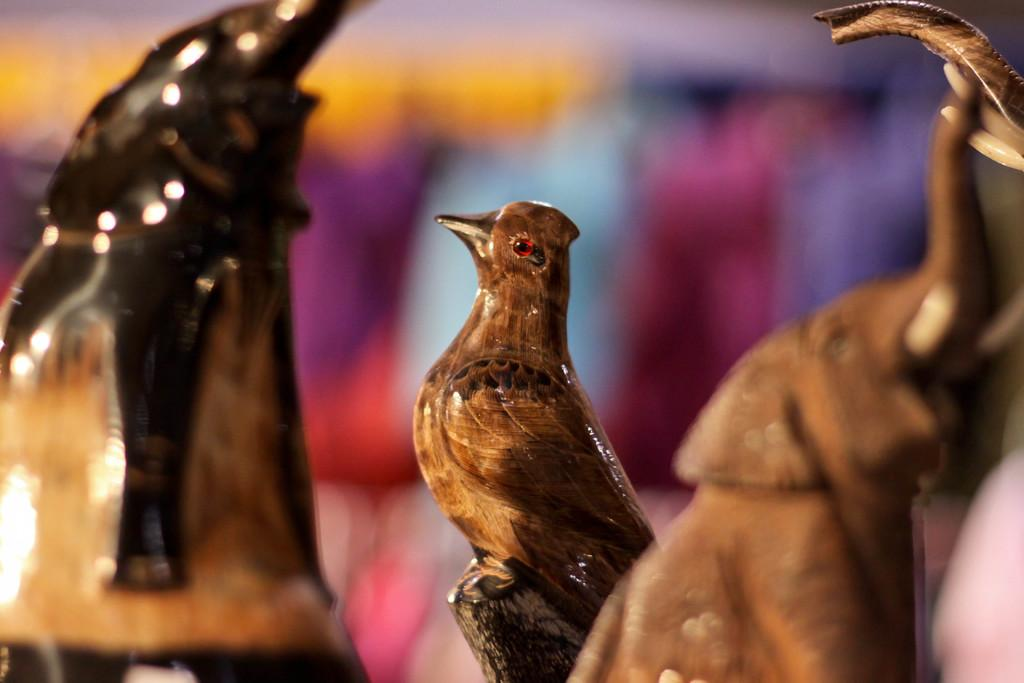What type of toys are present in the image? There are wooden toys in the image. Can you describe the background of the image? The background of the image is blurred. What type of silk is being used to cover the brain in the image? There is no brain or silk present in the image; it features wooden toys and a blurred background. 